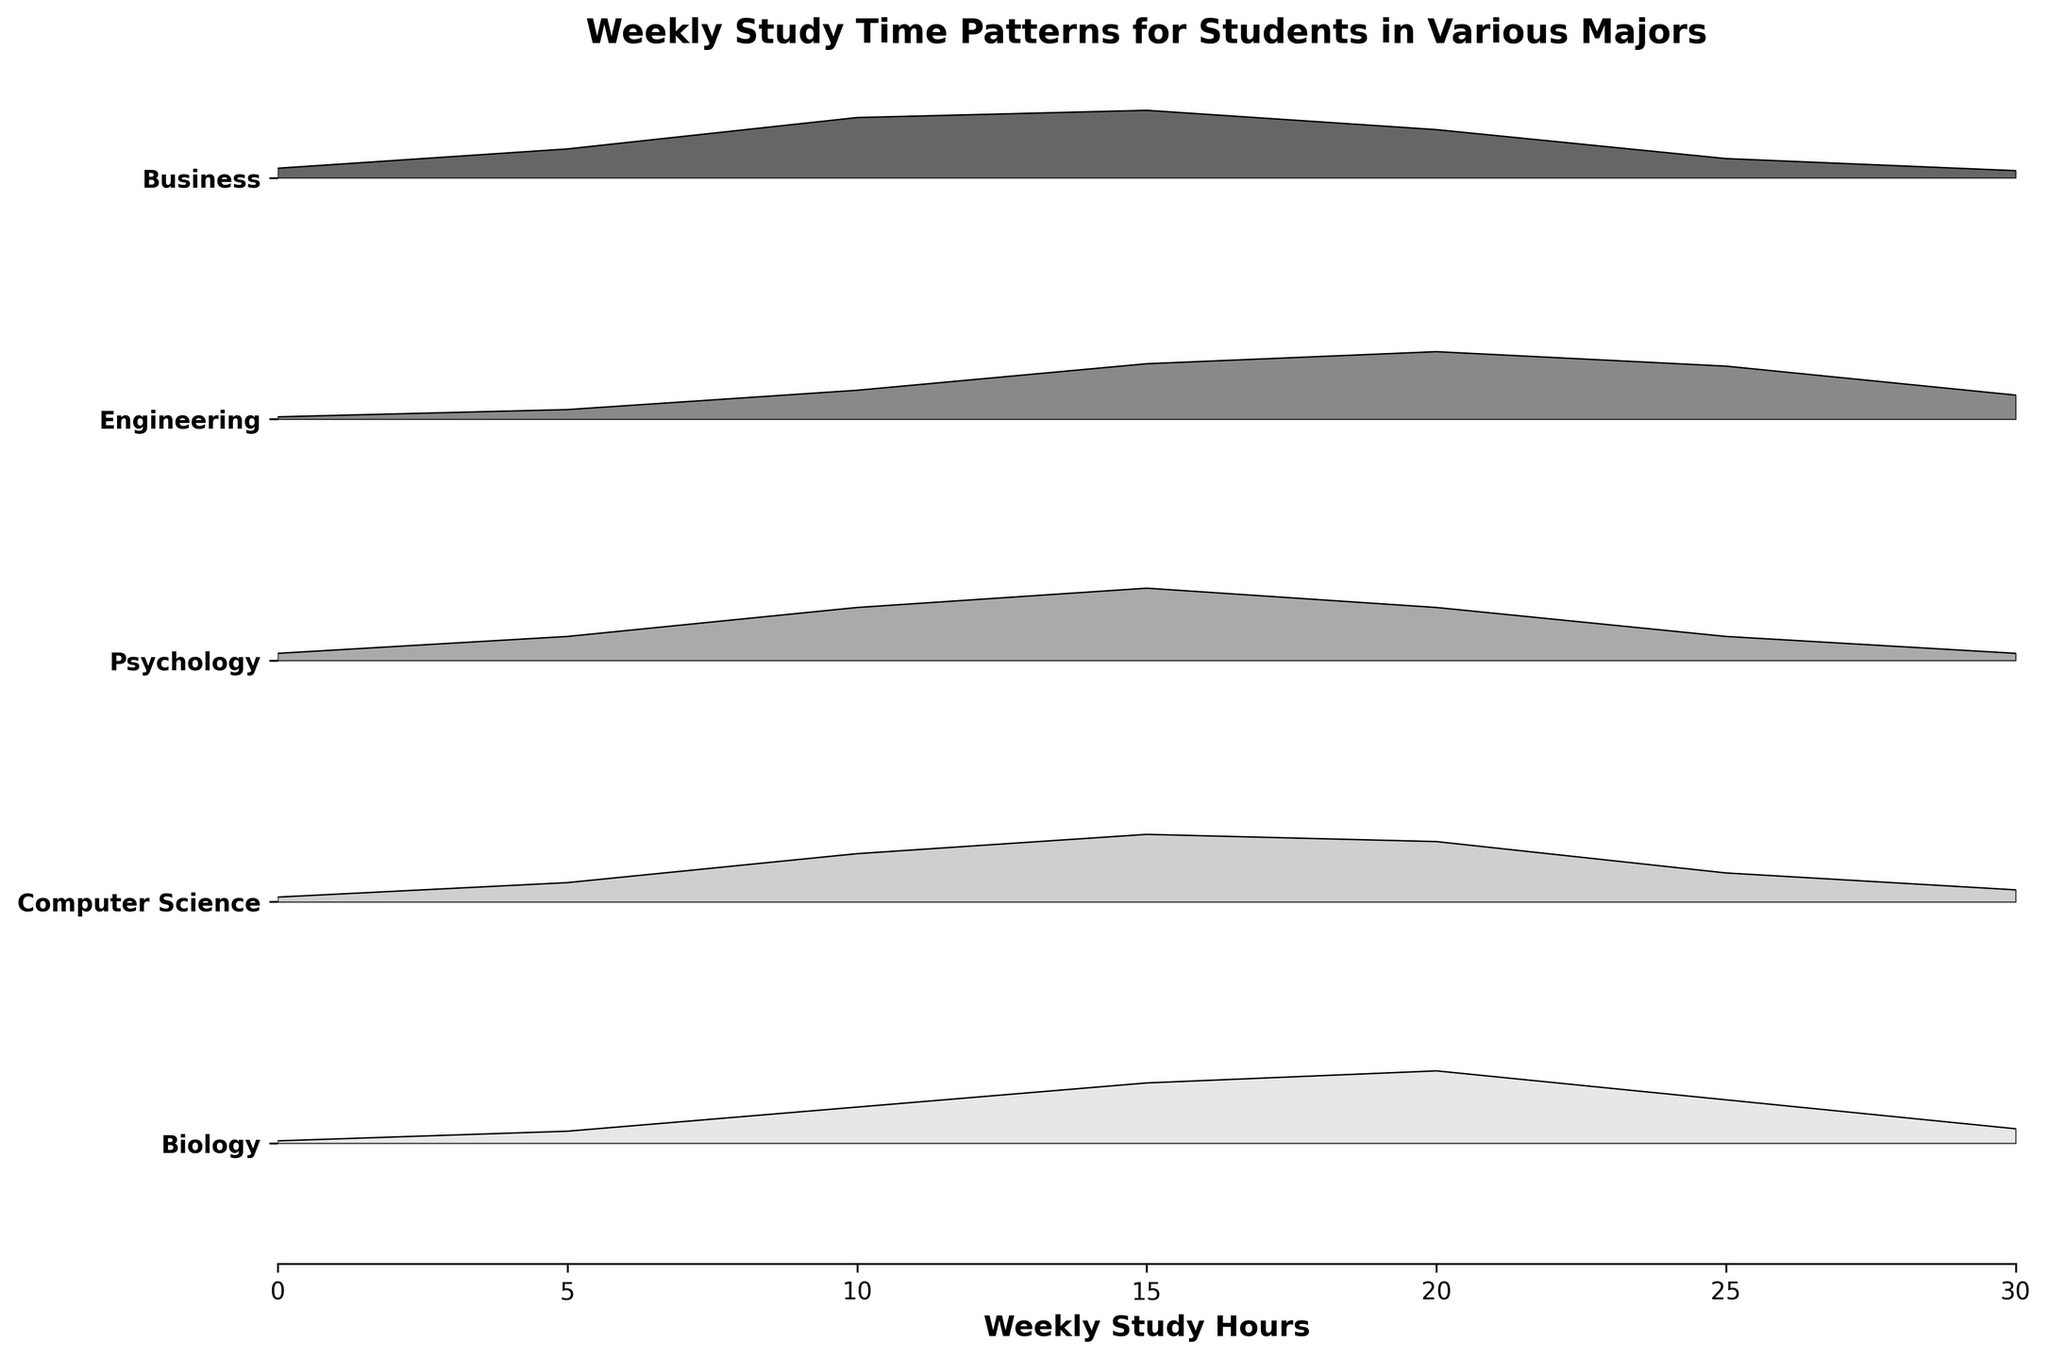What is the title of the plot? The title is usually located at the top of the figure and gives a brief description of what the plot is about. In this plot, the title is clearly displayed at the top.
Answer: Weekly Study Time Patterns for Students in Various Majors Which major shows the highest density for 20 weekly study hours? To find the highest density at 20 weekly study hours, look at the peaks around the 20-hour mark for each major. The major with the highest peak is the answer.
Answer: Biology How many majors are represented in the plot? Count the number of unique lines or ridges along the y-axis, each representing a different major. In this plot, each line corresponds to one major.
Answer: 5 Which major has the lowest density at 10 weekly study hours? To determine the major with the lowest density, compare the densities at the 10-hour mark for all majors. The major with the smallest peak is the answer.
Answer: Engineering What is the approximate density for Psychology at 15 weekly study hours? Locate the Psychology ridge and find the peak corresponding to 15 weekly study hours. The height of this peak represents the density value.
Answer: 0.30 Which major shows a more dispersed study time pattern between 0 to 30 hours? A dispersed study time pattern is indicated by a more spread-out density distribution curve. Compare the spread of all major curves to find the answer.
Answer: Engineering Compare the density of Business and Computer Science at 25 weekly study hours. Which is higher? Look at the density peaks around the 25-hour mark for both Business and Computer Science. The major with the higher peak indicates a higher density.
Answer: Computer Science In which range of weekly study hours does Business show the highest density? Identify the peak density value for the Business curve and see which range of hours it falls into. The highest peak indicates the answer.
Answer: 15 weekly study hours What is the most common weekly study hour range across all majors? The most common range can be inferred from the overlap or highest peaks of all curves combined. Notice where most peaks tend to occur.
Answer: 15-20 weekly study hours Is the density distribution of study hours symmetric for any major? A symmetric distribution would look like a mirror image on both sides of the peak. Review the curves to see if any appear uniformly mirrored around their peaks.
Answer: No 